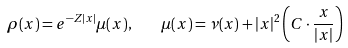<formula> <loc_0><loc_0><loc_500><loc_500>\rho ( x ) = e ^ { - Z | x | } \mu ( x ) , \quad \mu ( x ) = \nu ( x ) + | x | ^ { 2 } \left ( C \cdot \frac { x } { | x | } \right )</formula> 